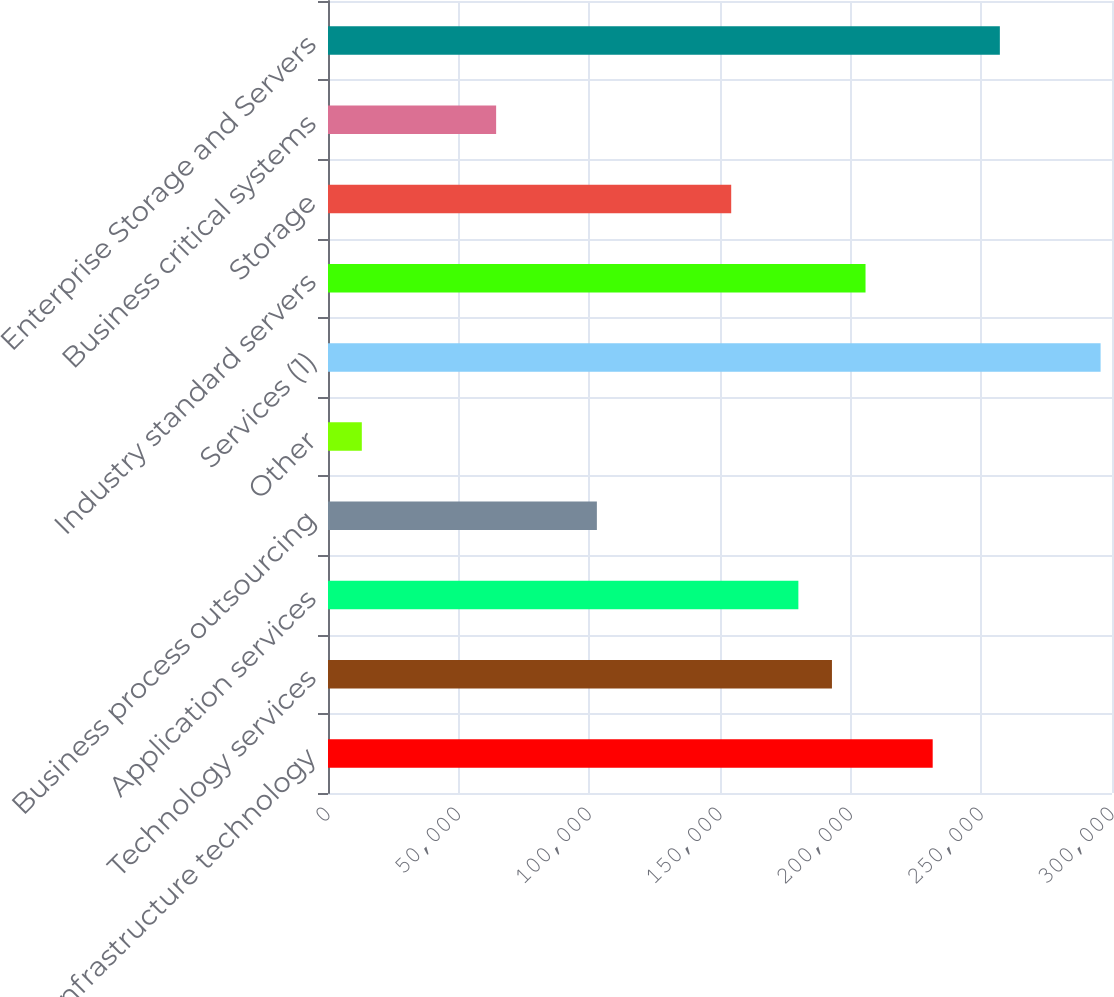Convert chart to OTSL. <chart><loc_0><loc_0><loc_500><loc_500><bar_chart><fcel>Infrastructure technology<fcel>Technology services<fcel>Application services<fcel>Business process outsourcing<fcel>Other<fcel>Services (1)<fcel>Industry standard servers<fcel>Storage<fcel>Business critical systems<fcel>Enterprise Storage and Servers<nl><fcel>231387<fcel>192837<fcel>179987<fcel>102887<fcel>12937<fcel>295637<fcel>205687<fcel>154287<fcel>64337<fcel>257087<nl></chart> 